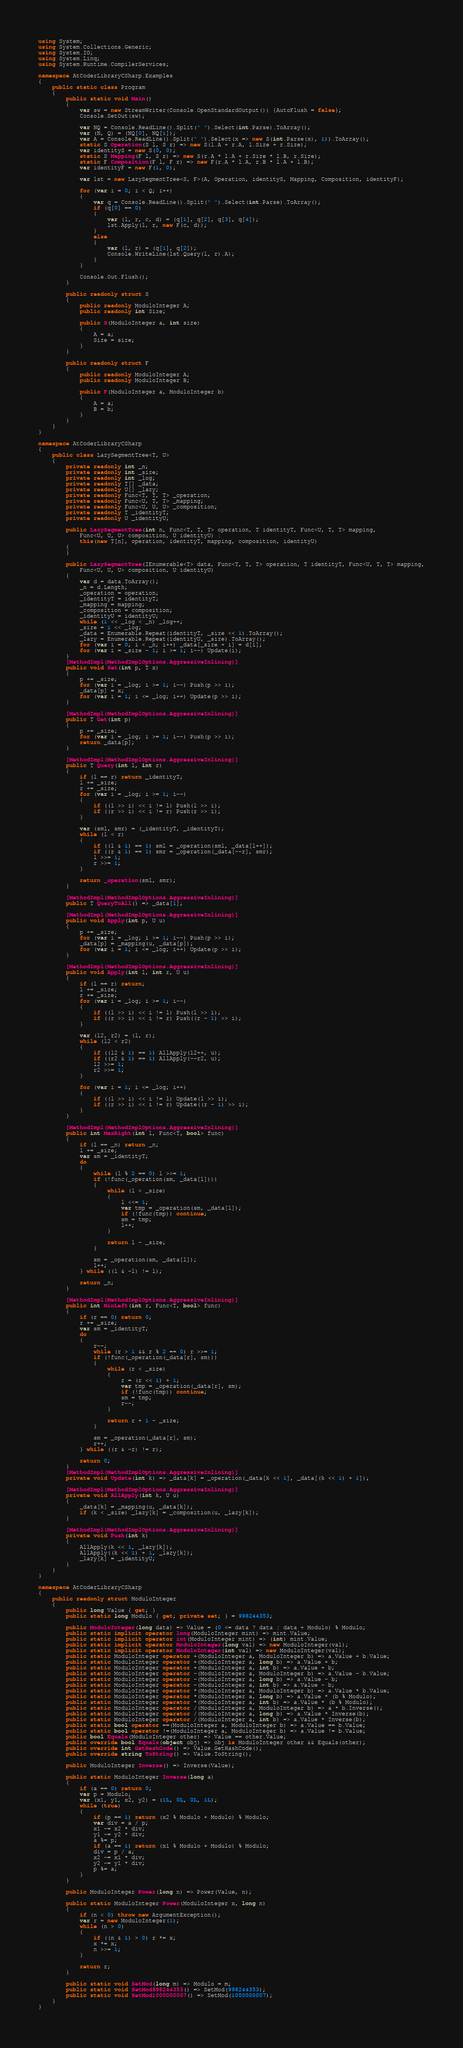<code> <loc_0><loc_0><loc_500><loc_500><_C#_>using System;
using System.Collections.Generic;
using System.IO;
using System.Linq;
using System.Runtime.CompilerServices;

namespace AtCoderLibraryCSharp.Examples
{
    public static class Program
    {
        public static void Main()
        {
            var sw = new StreamWriter(Console.OpenStandardOutput()) {AutoFlush = false};
            Console.SetOut(sw);

            var NQ = Console.ReadLine().Split(" ").Select(int.Parse).ToArray();
            var (N, Q) = (NQ[0], NQ[1]);
            var A = Console.ReadLine().Split(" ").Select(x => new S(int.Parse(x), 1)).ToArray();
            static S Operation(S l, S r) => new S(l.A + r.A, l.Size + r.Size);
            var identityS = new S(0, 0);
            static S Mapping(F l, S r) => new S(r.A * l.A + r.Size * l.B, r.Size);
            static F Composition(F l, F r) => new F(r.A * l.A, r.B * l.A + l.B);
            var identityF = new F(1, 0);

            var lst = new LazySegmentTree<S, F>(A, Operation, identityS, Mapping, Composition, identityF);

            for (var i = 0; i < Q; i++)
            {
                var q = Console.ReadLine().Split(" ").Select(int.Parse).ToArray();
                if (q[0] == 0)
                {
                    var (l, r, c, d) = (q[1], q[2], q[3], q[4]);
                    lst.Apply(l, r, new F(c, d));
                }
                else
                {
                    var (l, r) = (q[1], q[2]);
                    Console.WriteLine(lst.Query(l, r).A);
                }
            }

            Console.Out.Flush();
        }

        public readonly struct S
        {
            public readonly ModuloInteger A;
            public readonly int Size;

            public S(ModuloInteger a, int size)
            {
                A = a;
                Size = size;
            }
        }

        public readonly struct F
        {
            public readonly ModuloInteger A;
            public readonly ModuloInteger B;

            public F(ModuloInteger a, ModuloInteger b)
            {
                A = a;
                B = b;
            }
        }
    }
}

namespace AtCoderLibraryCSharp
{
    public class LazySegmentTree<T, U>
    {
        private readonly int _n;
        private readonly int _size;
        private readonly int _log;
        private readonly T[] _data;
        private readonly U[] _lazy;
        private readonly Func<T, T, T> _operation;
        private readonly Func<U, T, T> _mapping;
        private readonly Func<U, U, U> _composition;
        private readonly T _identityT;
        private readonly U _identityU;

        public LazySegmentTree(int n, Func<T, T, T> operation, T identityT, Func<U, T, T> mapping,
            Func<U, U, U> composition, U identityU) :
            this(new T[n], operation, identityT, mapping, composition, identityU)
        {
        }

        public LazySegmentTree(IEnumerable<T> data, Func<T, T, T> operation, T identityT, Func<U, T, T> mapping,
            Func<U, U, U> composition, U identityU)
        {
            var d = data.ToArray();
            _n = d.Length;
            _operation = operation;
            _identityT = identityT;
            _mapping = mapping;
            _composition = composition;
            _identityU = identityU;
            while (1 << _log < _n) _log++;
            _size = 1 << _log;
            _data = Enumerable.Repeat(identityT, _size << 1).ToArray();
            _lazy = Enumerable.Repeat(identityU, _size).ToArray();
            for (var i = 0; i < _n; i++) _data[_size + i] = d[i];
            for (var i = _size - 1; i >= 1; i--) Update(i);
        }
        [MethodImpl(MethodImplOptions.AggressiveInlining)]
        public void Set(int p, T x)
        {
            p += _size;
            for (var i = _log; i >= 1; i--) Push(p >> i);
            _data[p] = x;
            for (var i = 1; i <= _log; i++) Update(p >> i);
        }
        
        [MethodImpl(MethodImplOptions.AggressiveInlining)]
        public T Get(int p)
        {
            p += _size;
            for (var i = _log; i >= 1; i--) Push(p >> i);
            return _data[p];
        }
        
        [MethodImpl(MethodImplOptions.AggressiveInlining)]
        public T Query(int l, int r)
        {
            if (l == r) return _identityT;
            l += _size;
            r += _size;
            for (var i = _log; i >= 1; i--)
            {
                if ((l >> i) << i != l) Push(l >> i);
                if ((r >> i) << i != r) Push(r >> i);
            }

            var (sml, smr) = (_identityT, _identityT);
            while (l < r)
            {
                if ((l & 1) == 1) sml = _operation(sml, _data[l++]);
                if ((r & 1) == 1) smr = _operation(_data[--r], smr);
                l >>= 1;
                r >>= 1;
            }

            return _operation(sml, smr);
        }
        
        [MethodImpl(MethodImplOptions.AggressiveInlining)]
        public T QueryToAll() => _data[1];
        
        [MethodImpl(MethodImplOptions.AggressiveInlining)]
        public void Apply(int p, U u)
        {
            p += _size;
            for (var i = _log; i >= 1; i--) Push(p >> i);
            _data[p] = _mapping(u, _data[p]);
            for (var i = 1; i <= _log; i++) Update(p >> i);
        }

        [MethodImpl(MethodImplOptions.AggressiveInlining)]
        public void Apply(int l, int r, U u)
        {
            if (l == r) return;
            l += _size;
            r += _size;
            for (var i = _log; i >= 1; i--)
            {
                if ((l >> i) << i != l) Push(l >> i);
                if ((r >> i) << i != r) Push((r - 1) >> i);
            }

            var (l2, r2) = (l, r);
            while (l2 < r2)
            {
                if ((l2 & 1) == 1) AllApply(l2++, u);
                if ((r2 & 1) == 1) AllApply(--r2, u);
                l2 >>= 1;
                r2 >>= 1;
            }

            for (var i = 1; i <= _log; i++)
            {
                if ((l >> i) << i != l) Update(l >> i);
                if ((r >> i) << i != r) Update((r - 1) >> i);
            }
        }
        
        [MethodImpl(MethodImplOptions.AggressiveInlining)]
        public int MaxRight(int l, Func<T, bool> func)
        {
            if (l == _n) return _n;
            l += _size;
            var sm = _identityT;
            do
            {
                while (l % 2 == 0) l >>= 1;
                if (!func(_operation(sm, _data[l])))
                {
                    while (l < _size)
                    {
                        l <<= 1;
                        var tmp = _operation(sm, _data[l]);
                        if (!func(tmp)) continue;
                        sm = tmp;
                        l++;
                    }

                    return l - _size;
                }

                sm = _operation(sm, _data[l]);
                l++;
            } while ((l & -l) != l);

            return _n;
        }

        [MethodImpl(MethodImplOptions.AggressiveInlining)]
        public int MinLeft(int r, Func<T, bool> func)
        {
            if (r == 0) return 0;
            r += _size;
            var sm = _identityT;
            do
            {
                r--;
                while (r > 1 && r % 2 == 0) r >>= 1;
                if (!func(_operation(_data[r], sm)))
                {
                    while (r < _size)
                    {
                        r = (r << 1) + 1;
                        var tmp = _operation(_data[r], sm);
                        if (!func(tmp)) continue;
                        sm = tmp;
                        r--;
                    }

                    return r + 1 - _size;
                }

                sm = _operation(_data[r], sm);
                r++;
            } while ((r & -r) != r);

            return 0;
        }
        [MethodImpl(MethodImplOptions.AggressiveInlining)]
        private void Update(int k) => _data[k] = _operation(_data[k << 1], _data[(k << 1) + 1]);
        
        [MethodImpl(MethodImplOptions.AggressiveInlining)]
        private void AllApply(int k, U u)
        {
            _data[k] = _mapping(u, _data[k]);
            if (k < _size) _lazy[k] = _composition(u, _lazy[k]);
        }

        [MethodImpl(MethodImplOptions.AggressiveInlining)]
        private void Push(int k)
        {
            AllApply(k << 1, _lazy[k]);
            AllApply((k << 1) + 1, _lazy[k]);
            _lazy[k] = _identityU;
        }
    }
}

namespace AtCoderLibraryCSharp
{
    public readonly struct ModuloInteger
    {
        public long Value { get; }
        public static long Modulo { get; private set; } = 998244353;

        public ModuloInteger(long data) => Value = (0 <= data ? data : data + Modulo) % Modulo;
        public static implicit operator long(ModuloInteger mint) => mint.Value;
        public static implicit operator int(ModuloInteger mint) => (int) mint.Value;
        public static implicit operator ModuloInteger(long val) => new ModuloInteger(val);
        public static implicit operator ModuloInteger(int val) => new ModuloInteger(val);
        public static ModuloInteger operator +(ModuloInteger a, ModuloInteger b) => a.Value + b.Value;
        public static ModuloInteger operator +(ModuloInteger a, long b) => a.Value + b;
        public static ModuloInteger operator +(ModuloInteger a, int b) => a.Value + b;
        public static ModuloInteger operator -(ModuloInteger a, ModuloInteger b) => a.Value - b.Value;
        public static ModuloInteger operator -(ModuloInteger a, long b) => a.Value - b;
        public static ModuloInteger operator -(ModuloInteger a, int b) => a.Value - b;
        public static ModuloInteger operator *(ModuloInteger a, ModuloInteger b) => a.Value * b.Value;
        public static ModuloInteger operator *(ModuloInteger a, long b) => a.Value * (b % Modulo);
        public static ModuloInteger operator *(ModuloInteger a, int b) => a.Value * (b % Modulo);
        public static ModuloInteger operator /(ModuloInteger a, ModuloInteger b) => a * b.Inverse();
        public static ModuloInteger operator /(ModuloInteger a, long b) => a.Value * Inverse(b);
        public static ModuloInteger operator /(ModuloInteger a, int b) => a.Value * Inverse(b);
        public static bool operator ==(ModuloInteger a, ModuloInteger b) => a.Value == b.Value;
        public static bool operator !=(ModuloInteger a, ModuloInteger b) => a.Value != b.Value;
        public bool Equals(ModuloInteger other) => Value == other.Value;
        public override bool Equals(object obj) => obj is ModuloInteger other && Equals(other);
        public override int GetHashCode() => Value.GetHashCode();
        public override string ToString() => Value.ToString();

        public ModuloInteger Inverse() => Inverse(Value);

        public static ModuloInteger Inverse(long a)
        {
            if (a == 0) return 0;
            var p = Modulo;
            var (x1, y1, x2, y2) = (1L, 0L, 0L, 1L);
            while (true)
            {
                if (p == 1) return (x2 % Modulo + Modulo) % Modulo;
                var div = a / p;
                x1 -= x2 * div;
                y1 -= y2 * div;
                a %= p;
                if (a == 1) return (x1 % Modulo + Modulo) % Modulo;
                div = p / a;
                x2 -= x1 * div;
                y2 -= y1 * div;
                p %= a;
            }
        }

        public ModuloInteger Power(long n) => Power(Value, n);

        public static ModuloInteger Power(ModuloInteger x, long n)
        {
            if (n < 0) throw new ArgumentException();
            var r = new ModuloInteger(1);
            while (n > 0)
            {
                if ((n & 1) > 0) r *= x;
                x *= x;
                n >>= 1;
            }

            return r;
        }

        public static void SetMod(long m) => Modulo = m;
        public static void SetMod998244353() => SetMod(998244353);
        public static void SetMod1000000007() => SetMod(1000000007);
    }
}</code> 